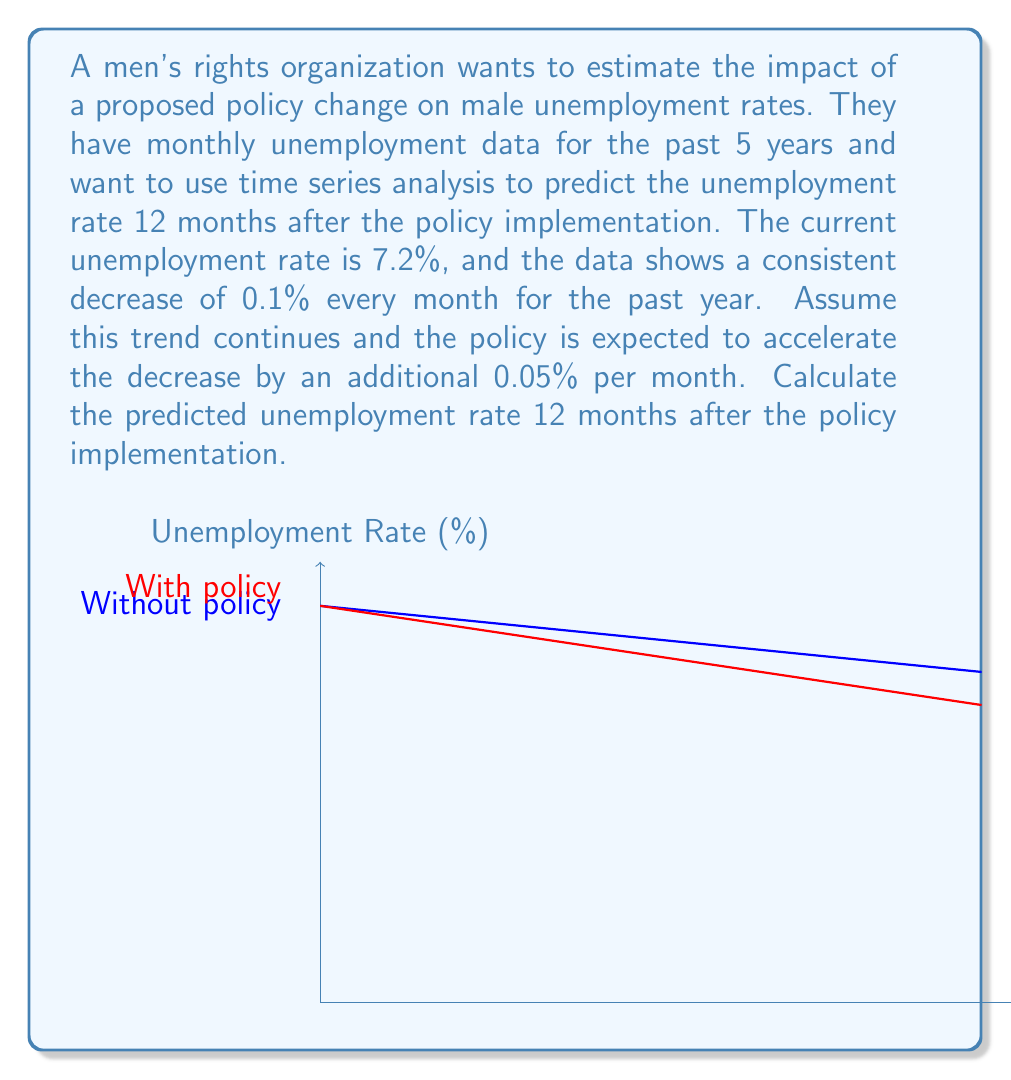What is the answer to this math problem? Let's approach this step-by-step:

1) First, let's define our variables:
   $u_0$ = initial unemployment rate = 7.2%
   $r_1$ = monthly rate of decrease without policy = 0.1%
   $r_2$ = additional monthly rate of decrease due to policy = 0.05%
   $t$ = time in months = 12

2) The total monthly rate of decrease after policy implementation:
   $r = r_1 + r_2 = 0.1% + 0.05% = 0.15%$

3) We can model this as a linear function:
   $u(t) = u_0 - r \cdot t$

4) Substituting our values:
   $u(12) = 7.2% - 0.15% \cdot 12$

5) Calculating:
   $u(12) = 7.2% - 1.8% = 5.4%$

Therefore, the predicted unemployment rate 12 months after policy implementation is 5.4%.
Answer: 5.4% 